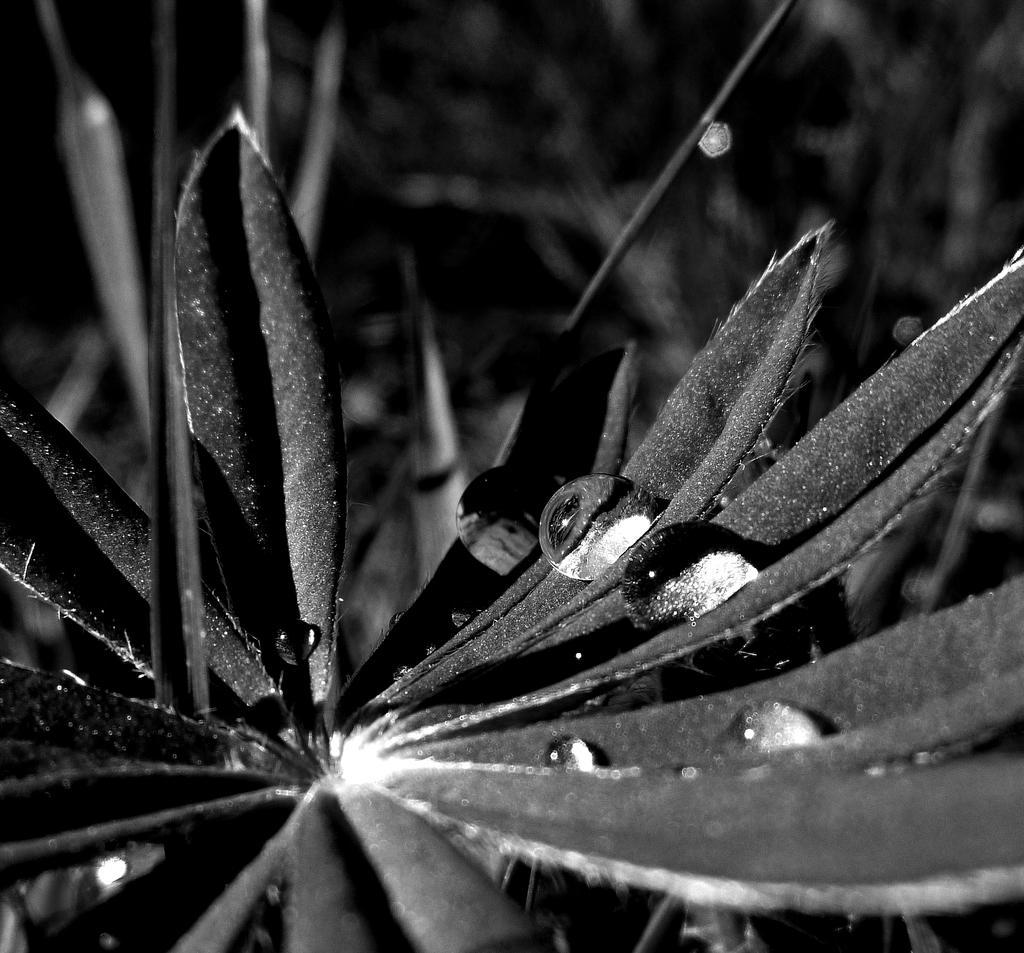How would you summarize this image in a sentence or two? In this image we can see water drops on the leaves of a flower, also we can see the background is blurred, and the picture is taken in black and white mode. 